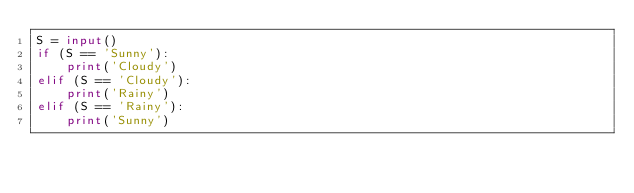Convert code to text. <code><loc_0><loc_0><loc_500><loc_500><_Python_>S = input()
if (S == 'Sunny'):
    print('Cloudy')
elif (S == 'Cloudy'):
    print('Rainy')
elif (S == 'Rainy'):
    print('Sunny')
</code> 